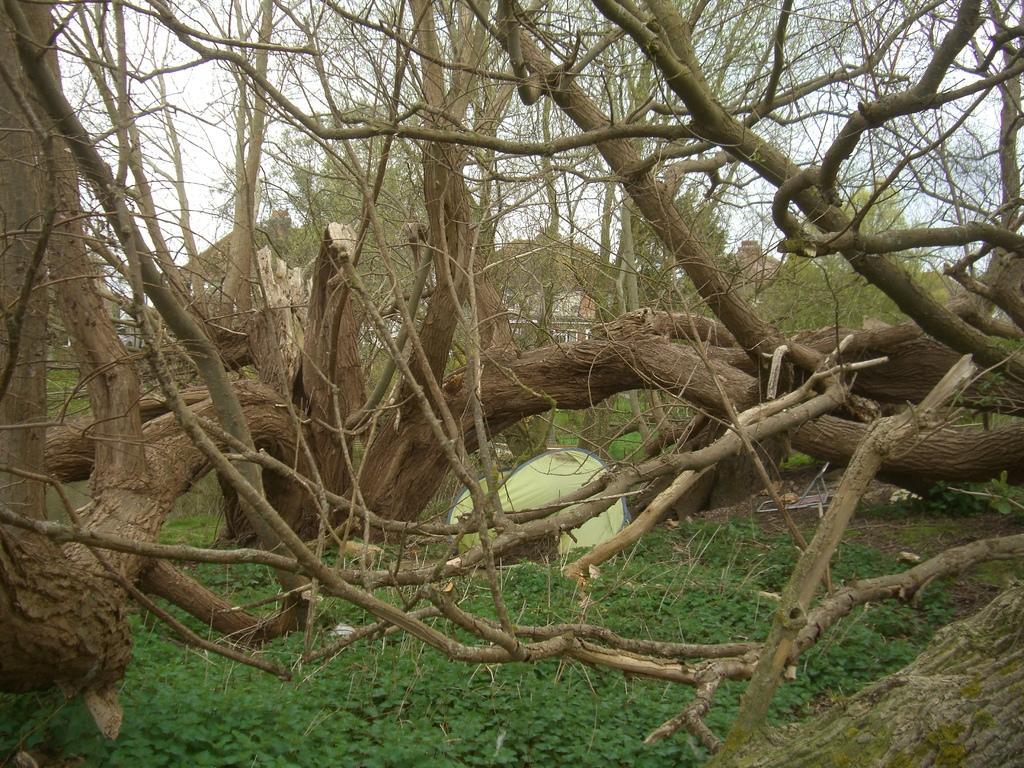Describe this image in one or two sentences. In this picture we can see trees and grass. 